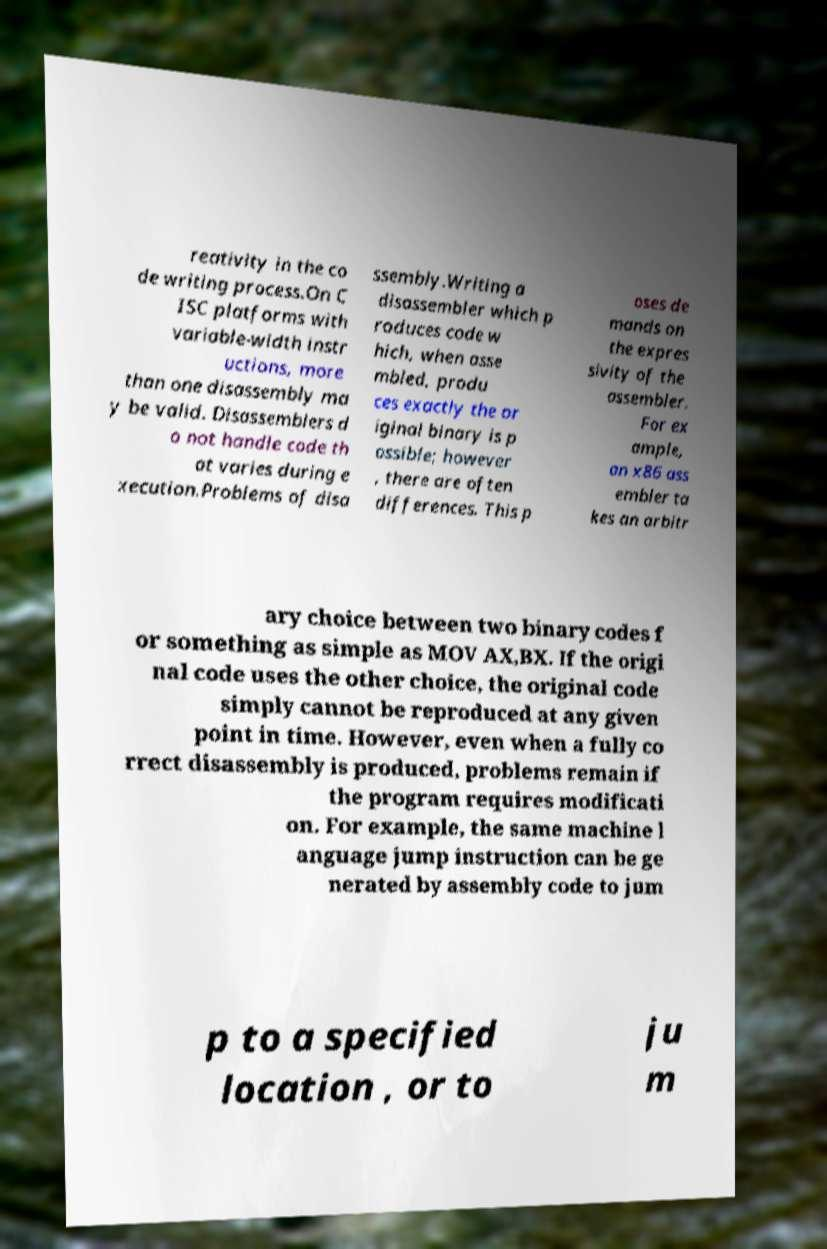Could you extract and type out the text from this image? reativity in the co de writing process.On C ISC platforms with variable-width instr uctions, more than one disassembly ma y be valid. Disassemblers d o not handle code th at varies during e xecution.Problems of disa ssembly.Writing a disassembler which p roduces code w hich, when asse mbled, produ ces exactly the or iginal binary is p ossible; however , there are often differences. This p oses de mands on the expres sivity of the assembler. For ex ample, an x86 ass embler ta kes an arbitr ary choice between two binary codes f or something as simple as MOV AX,BX. If the origi nal code uses the other choice, the original code simply cannot be reproduced at any given point in time. However, even when a fully co rrect disassembly is produced, problems remain if the program requires modificati on. For example, the same machine l anguage jump instruction can be ge nerated by assembly code to jum p to a specified location , or to ju m 